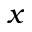Convert formula to latex. <formula><loc_0><loc_0><loc_500><loc_500>x</formula> 